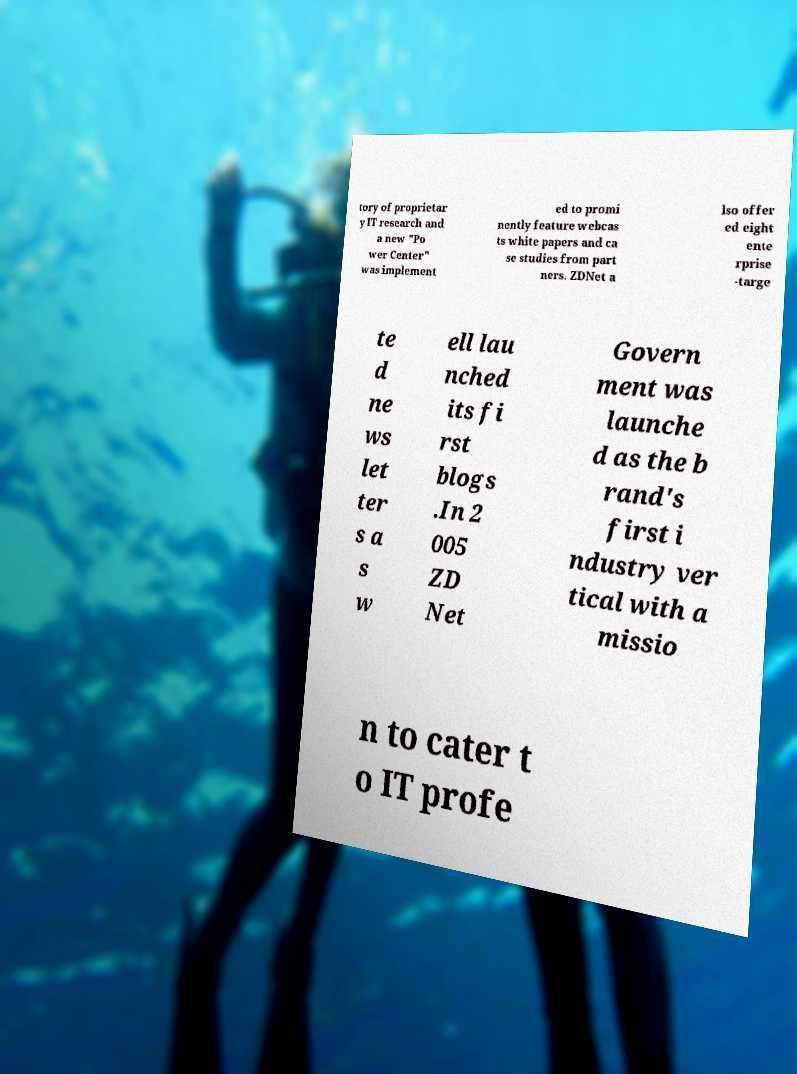Could you extract and type out the text from this image? tory of proprietar y IT research and a new "Po wer Center" was implement ed to promi nently feature webcas ts white papers and ca se studies from part ners. ZDNet a lso offer ed eight ente rprise -targe te d ne ws let ter s a s w ell lau nched its fi rst blogs .In 2 005 ZD Net Govern ment was launche d as the b rand's first i ndustry ver tical with a missio n to cater t o IT profe 